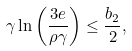Convert formula to latex. <formula><loc_0><loc_0><loc_500><loc_500>\gamma \ln \left ( \frac { 3 e } { \rho \gamma } \right ) \leq \frac { b _ { 2 } } { 2 } ,</formula> 